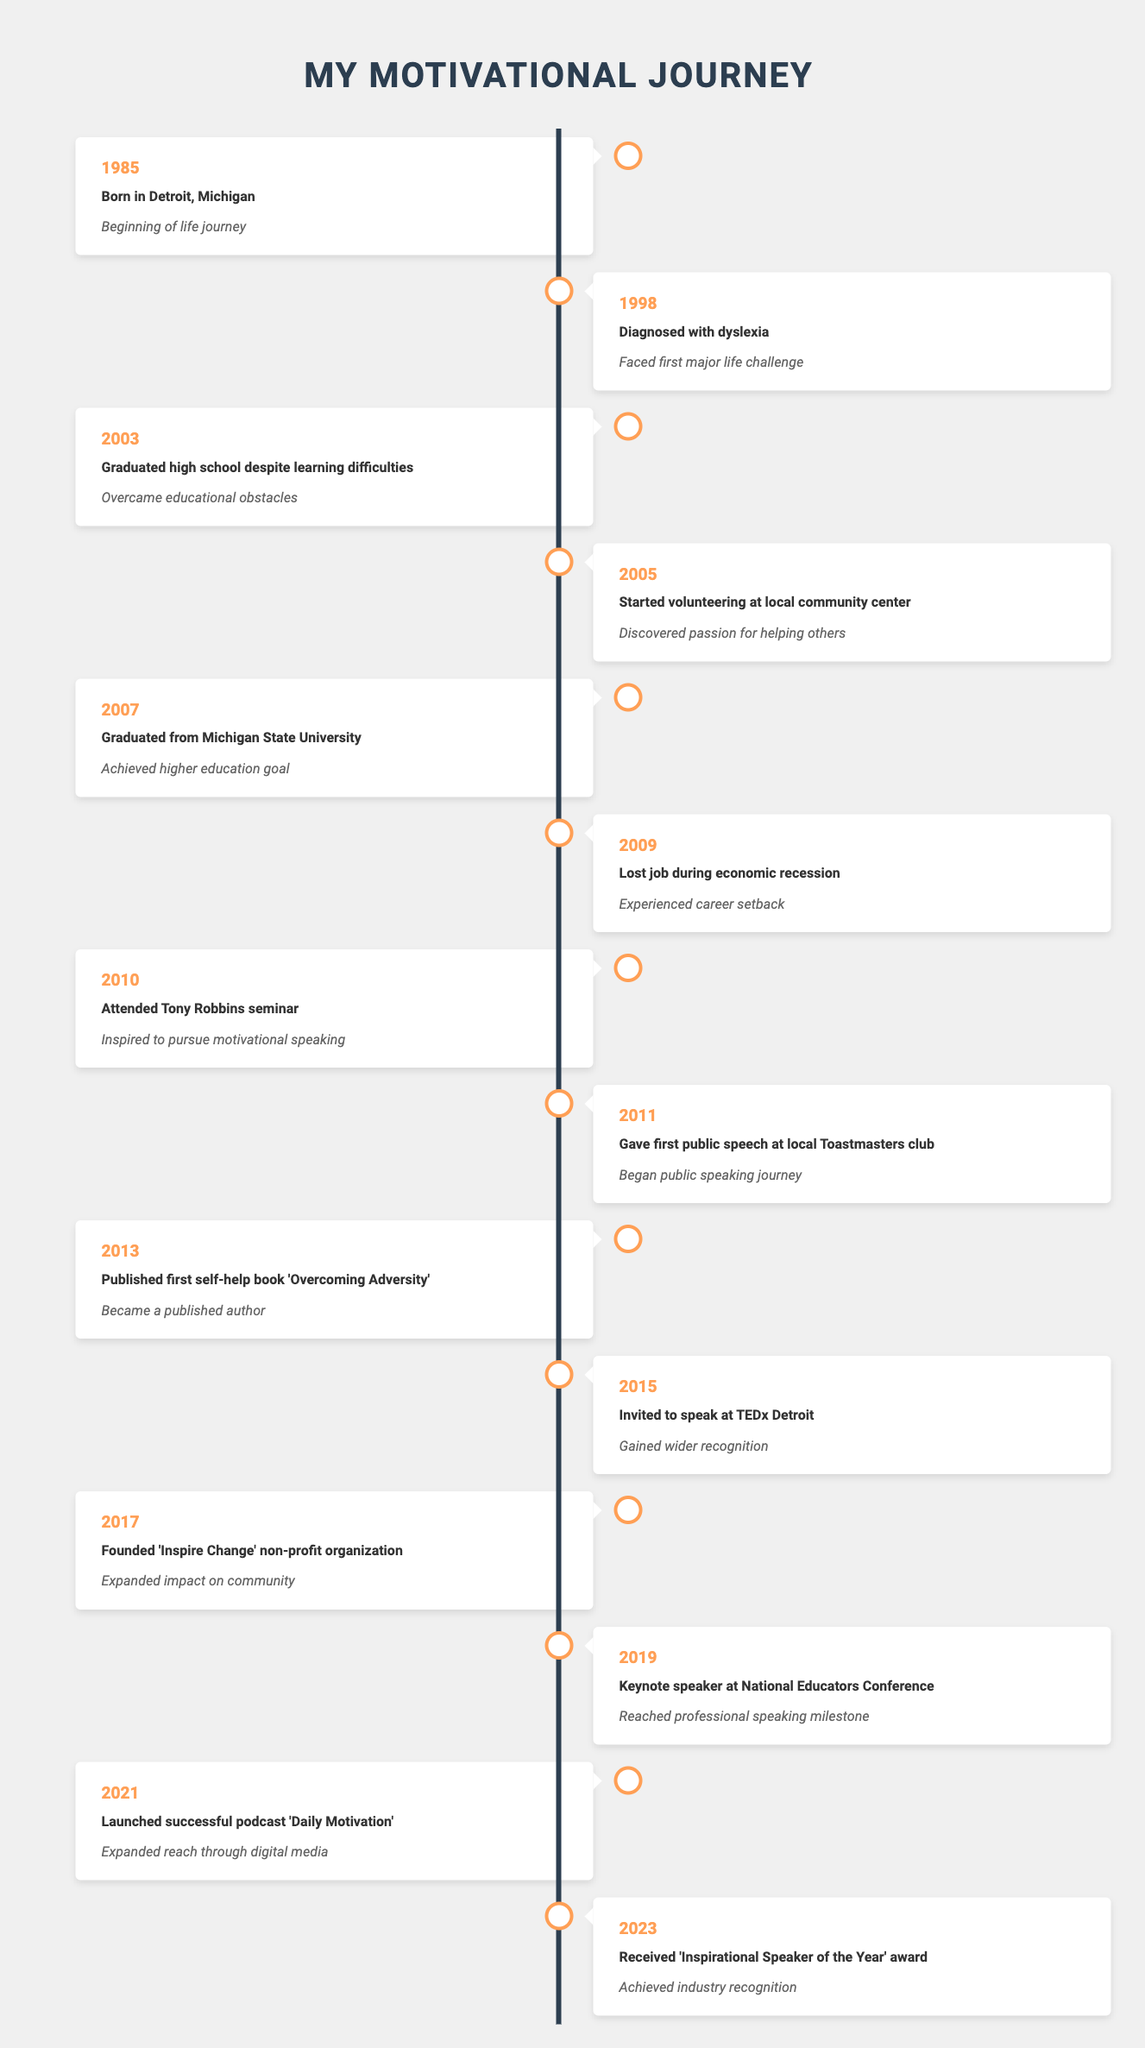What year did you graduate from Michigan State University? The table lists the event "Graduated from Michigan State University" under the year 2007, so the answer can be directly found there.
Answer: 2007 What significant event occurred in 2013? The table indicates that in 2013, you published your first self-help book titled 'Overcoming Adversity', marking the achievement of becoming a published author.
Answer: Published first self-help book 'Overcoming Adversity' In which year was the first public speech given? Referring to the year 2011 in the table, it shows that you gave your first public speech at a local Toastmasters club, indicating it was a milestone in that year.
Answer: 2011 Was volunteering at the local community center an early or late milestone in your journey? The timeline shows that volunteering began in 2005, which is relatively early in your journey after graduating high school in 2003, thus it can be considered an early milestone.
Answer: Early How many years passed between being diagnosed with dyslexia and graduating high school? The diagnosis occurred in 1998 and high school graduation was in 2003. To find the difference, subtract 1998 from 2003: 2003 - 1998 = 5 years.
Answer: 5 years What is the significance of the year 2021? According to the table, in 2021, you launched the successful podcast 'Daily Motivation', which expanded your reach through digital media, highlighting a pivotal growth moment in your journey.
Answer: Launched successful podcast 'Daily Motivation' Did you receive any awards before 2023? The table does not indicate any awards received prior to 2023, when you received the 'Inspirational Speaker of the Year' award, suggesting no earlier awards were noted in your timeline.
Answer: No Which year marks the founding of the 'Inspire Change' non-profit organization? The table clearly states that the 'Inspire Change' non-profit organization was founded in 2017, highlighting a significant expansion of your impact on the community.
Answer: 2017 What were the key milestones in your professional speaking journey from 2010 to 2019? From the timeline, in 2010 you attended a Tony Robbins seminar, inspiring you to pursue motivational speaking. Then in 2011, you gave your first public speech, followed by keynote speaking at the National Educators Conference in 2019. Therefore, the key milestones during this period are the seminar, your first speech, and becoming a keynote speaker.
Answer: Seminar in 2010, first speech in 2011, keynote in 2019 